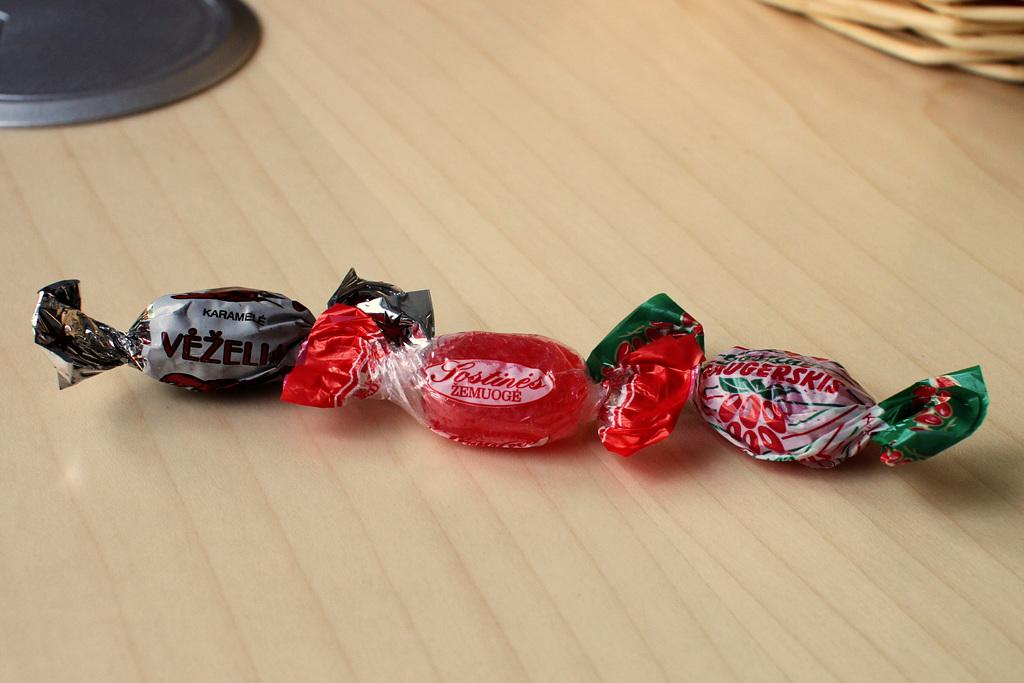What type of candies are on the wooden table in the image? There are three toffees on a wooden table in the image. Can you describe the object at the top of the image? Unfortunately, the facts provided do not give any information about the object at the top of the image. What else is on the wooden table besides the toffees? There is a basket on the table. What type of oil can be seen dripping from the toffees in the image? There is no oil present in the image, and the toffees are not depicted as dripping anything. 